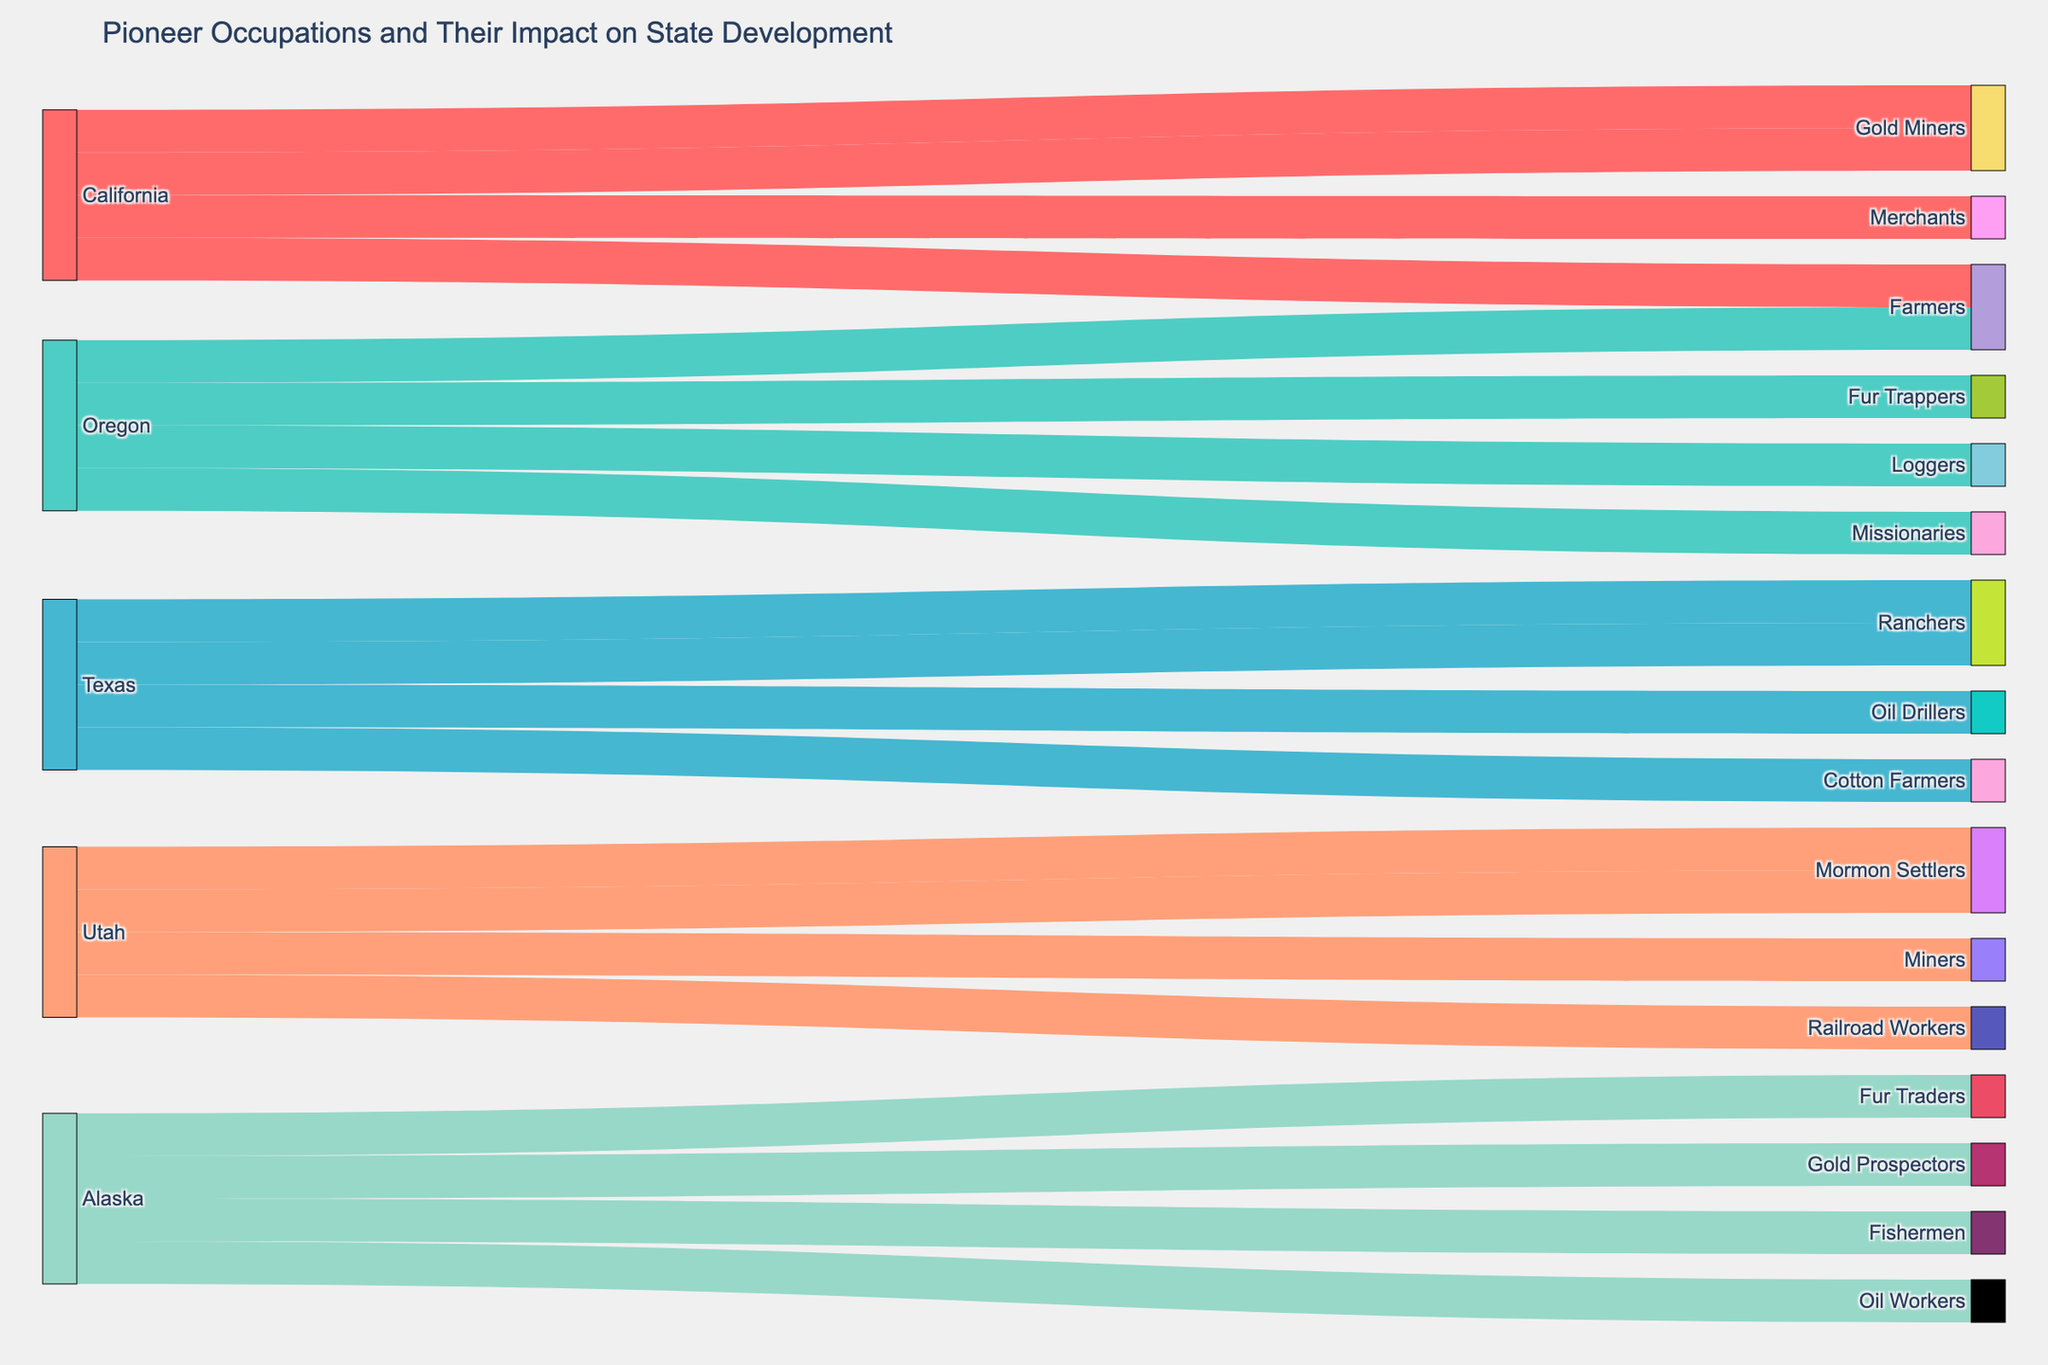What occupations are associated with California in the figure? The occupations associated with California as visualized in the figure are Gold Miners, Farmers, and Merchants.
Answer: Gold Miners, Farmers, Merchants How many different impacts are shown in the figure for Texas? The figure shows that Texas has four different impacts: Cattle Industry, Land Development, Industrial Revolution, and Agricultural Economy.
Answer: Four Which state has the occupation of Fur Traders, and what is their impact? By tracing the occupation of Fur Traders in the figure, we find that they are associated with Alaska, and their impact is Economic Foundation.
Answer: Alaska, Economic Foundation What impact did Farmers have in California? The figure shows that Farmers in California had the impact of Agricultural Development.
Answer: Agricultural Development Compare the number of occupations between Utah and Oregon. Which state has more? Utah has four occupations: Mormon Settlers, Miners, and Railroad Workers. Oregon also has four occupations: Fur Trappers, Farmers, Loggers, and Missionaries. Both states have the same number of occupations.
Answer: Same number What are the two impacts of the Mormon Settlers in Utah? By tracking the Mormon Settlers in Utah, the two impacts are Religious Community and Irrigation Systems.
Answer: Religious Community, Irrigation Systems Which occupation in Alaska contributed to Population Influx? In the figure, Population Influx in Alaska is connected to Gold Prospectors.
Answer: Gold Prospectors How does the impact of Religious Community in Utah compare to the Timber Industry Growth in Oregon? The impact of Religious Community in Utah comes from Mormon Settlers, while the impact of Timber Industry Growth in Oregon is due to Loggers. Both impacts are visualized clearly in the figure to emphasize the distinct occupational contributions.
Answer: Different occupations How does the figure illustrate the connection between Oil Drillers in Texas and their impact? The figure shows a direct link between Oil Drillers in Texas leading to the Industrial Revolution. This relationship is visualized through connected nodes representing Texas, Oil Drillers, and Industrial Revolution.
Answer: Oil Drillers to Industrial Revolution What state has the impact of Energy Sector Growth, and what is the occupation leading to it? The state with the impact of Energy Sector Growth is Alaska, and this is due to the occupation of Oil Workers.
Answer: Alaska, Oil Workers 